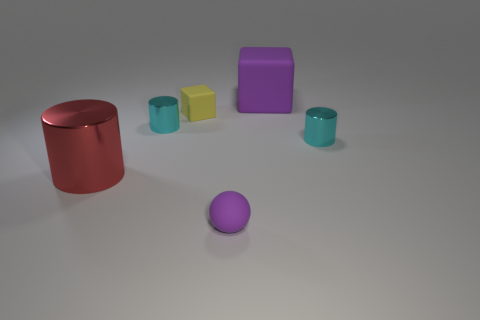What size is the block that is the same color as the small matte ball?
Your response must be concise. Large. Are there any blocks in front of the tiny yellow matte thing?
Give a very brief answer. No. Are there more small yellow things that are on the right side of the big cube than small shiny cylinders that are in front of the tiny yellow rubber cube?
Keep it short and to the point. No. What is the size of the yellow matte object that is the same shape as the big purple rubber object?
Your answer should be compact. Small. How many cylinders are tiny cyan things or red metal objects?
Provide a short and direct response. 3. What is the material of the ball that is the same color as the big matte object?
Offer a very short reply. Rubber. Is the number of tiny yellow matte blocks in front of the yellow rubber cube less than the number of large red cylinders to the left of the red cylinder?
Your response must be concise. No. How many things are tiny things that are to the left of the small rubber block or tiny purple matte objects?
Provide a succinct answer. 2. There is a big thing that is in front of the big thing that is right of the small yellow matte thing; what is its shape?
Offer a terse response. Cylinder. Are there any yellow rubber objects of the same size as the red shiny cylinder?
Offer a terse response. No. 